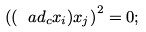Convert formula to latex. <formula><loc_0><loc_0><loc_500><loc_500>\left ( ( \ a d _ { c } x _ { i } ) x _ { j } \right ) ^ { 2 } = 0 ;</formula> 